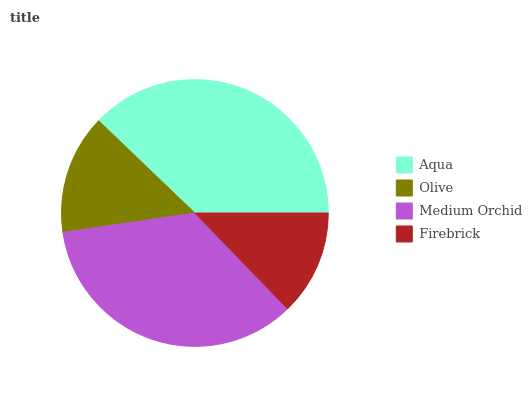Is Firebrick the minimum?
Answer yes or no. Yes. Is Aqua the maximum?
Answer yes or no. Yes. Is Olive the minimum?
Answer yes or no. No. Is Olive the maximum?
Answer yes or no. No. Is Aqua greater than Olive?
Answer yes or no. Yes. Is Olive less than Aqua?
Answer yes or no. Yes. Is Olive greater than Aqua?
Answer yes or no. No. Is Aqua less than Olive?
Answer yes or no. No. Is Medium Orchid the high median?
Answer yes or no. Yes. Is Olive the low median?
Answer yes or no. Yes. Is Aqua the high median?
Answer yes or no. No. Is Medium Orchid the low median?
Answer yes or no. No. 